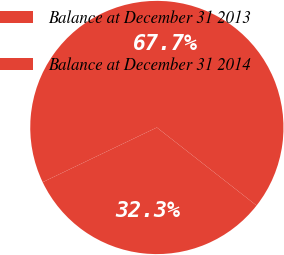Convert chart to OTSL. <chart><loc_0><loc_0><loc_500><loc_500><pie_chart><fcel>Balance at December 31 2013<fcel>Balance at December 31 2014<nl><fcel>32.32%<fcel>67.68%<nl></chart> 